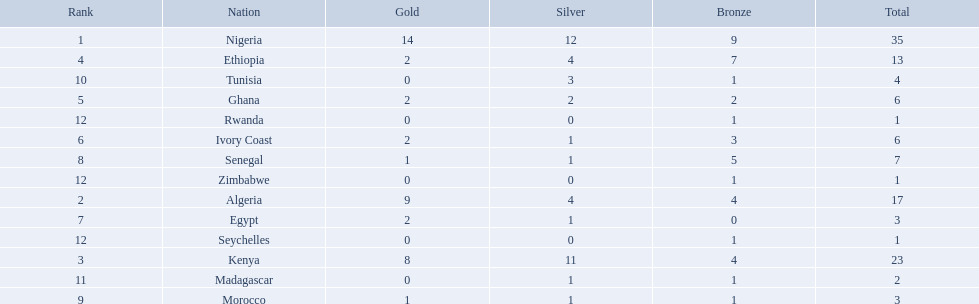What nations competed at the 1989 african championships in athletics? Nigeria, Algeria, Kenya, Ethiopia, Ghana, Ivory Coast, Egypt, Senegal, Morocco, Tunisia, Madagascar, Rwanda, Zimbabwe, Seychelles. What nations earned bronze medals? Nigeria, Algeria, Kenya, Ethiopia, Ghana, Ivory Coast, Senegal, Morocco, Tunisia, Madagascar, Rwanda, Zimbabwe, Seychelles. What nation did not earn a bronze medal? Egypt. 